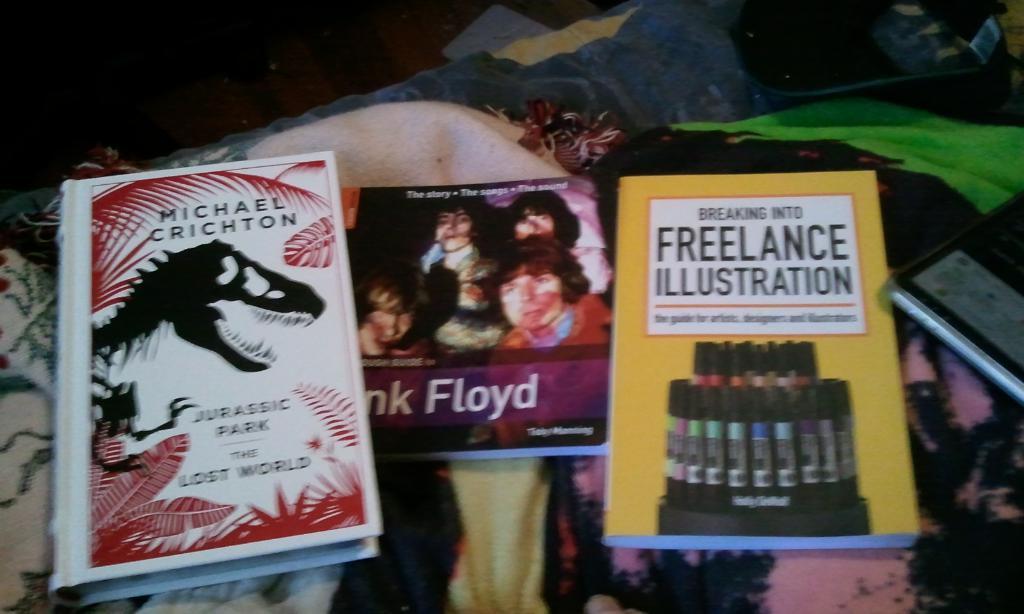What does this book help you break into?
Provide a succinct answer. Freelance illustration. 